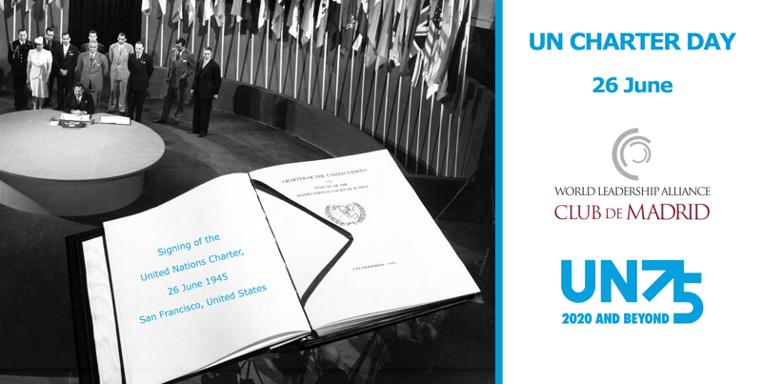When and where was the United Nations Charter signed? The historic signing of the United Nations Charter took place on 26 June 1945 in San Francisco, United States, during the United Nations Conference on International Organization. This event was attended by delegates from 50 nations and marked the beginning of a new global effort to promote peace and cooperation. 